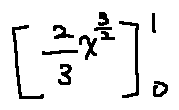<formula> <loc_0><loc_0><loc_500><loc_500>[ \frac { 2 } { 3 } x ^ { \frac { 3 } { 2 } } ] _ { 0 } ^ { 1 }</formula> 